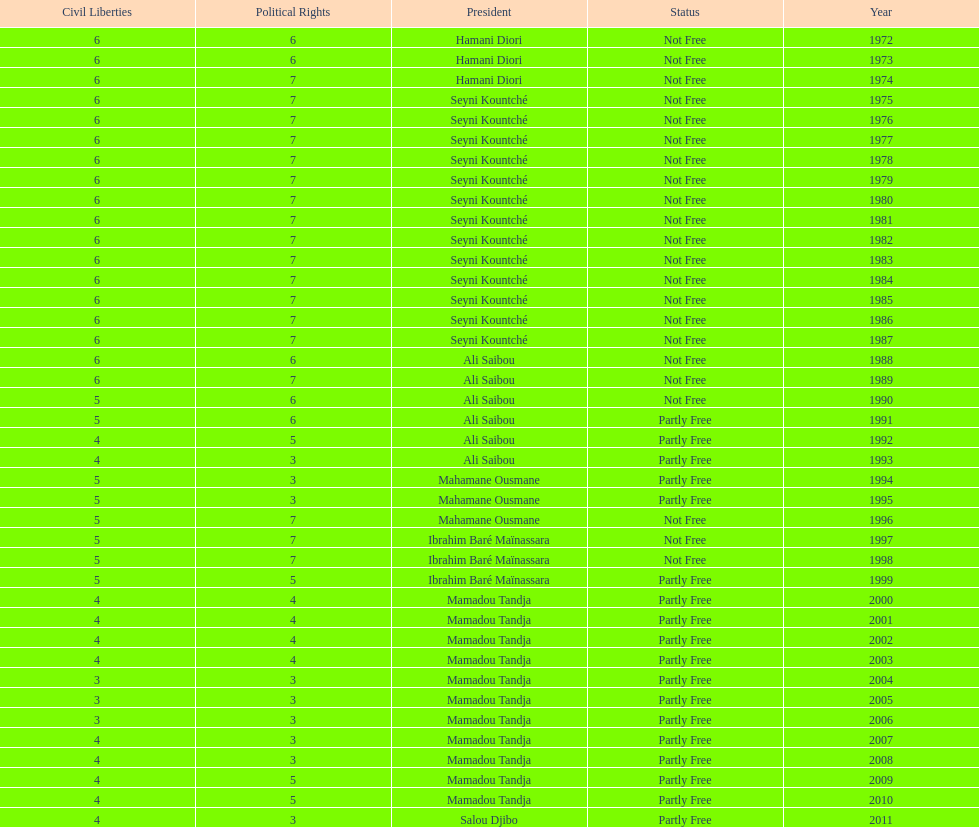Who was president before mamadou tandja? Ibrahim Baré Maïnassara. Could you parse the entire table? {'header': ['Civil Liberties', 'Political Rights', 'President', 'Status', 'Year'], 'rows': [['6', '6', 'Hamani Diori', 'Not Free', '1972'], ['6', '6', 'Hamani Diori', 'Not Free', '1973'], ['6', '7', 'Hamani Diori', 'Not Free', '1974'], ['6', '7', 'Seyni Kountché', 'Not Free', '1975'], ['6', '7', 'Seyni Kountché', 'Not Free', '1976'], ['6', '7', 'Seyni Kountché', 'Not Free', '1977'], ['6', '7', 'Seyni Kountché', 'Not Free', '1978'], ['6', '7', 'Seyni Kountché', 'Not Free', '1979'], ['6', '7', 'Seyni Kountché', 'Not Free', '1980'], ['6', '7', 'Seyni Kountché', 'Not Free', '1981'], ['6', '7', 'Seyni Kountché', 'Not Free', '1982'], ['6', '7', 'Seyni Kountché', 'Not Free', '1983'], ['6', '7', 'Seyni Kountché', 'Not Free', '1984'], ['6', '7', 'Seyni Kountché', 'Not Free', '1985'], ['6', '7', 'Seyni Kountché', 'Not Free', '1986'], ['6', '7', 'Seyni Kountché', 'Not Free', '1987'], ['6', '6', 'Ali Saibou', 'Not Free', '1988'], ['6', '7', 'Ali Saibou', 'Not Free', '1989'], ['5', '6', 'Ali Saibou', 'Not Free', '1990'], ['5', '6', 'Ali Saibou', 'Partly Free', '1991'], ['4', '5', 'Ali Saibou', 'Partly Free', '1992'], ['4', '3', 'Ali Saibou', 'Partly Free', '1993'], ['5', '3', 'Mahamane Ousmane', 'Partly Free', '1994'], ['5', '3', 'Mahamane Ousmane', 'Partly Free', '1995'], ['5', '7', 'Mahamane Ousmane', 'Not Free', '1996'], ['5', '7', 'Ibrahim Baré Maïnassara', 'Not Free', '1997'], ['5', '7', 'Ibrahim Baré Maïnassara', 'Not Free', '1998'], ['5', '5', 'Ibrahim Baré Maïnassara', 'Partly Free', '1999'], ['4', '4', 'Mamadou Tandja', 'Partly Free', '2000'], ['4', '4', 'Mamadou Tandja', 'Partly Free', '2001'], ['4', '4', 'Mamadou Tandja', 'Partly Free', '2002'], ['4', '4', 'Mamadou Tandja', 'Partly Free', '2003'], ['3', '3', 'Mamadou Tandja', 'Partly Free', '2004'], ['3', '3', 'Mamadou Tandja', 'Partly Free', '2005'], ['3', '3', 'Mamadou Tandja', 'Partly Free', '2006'], ['4', '3', 'Mamadou Tandja', 'Partly Free', '2007'], ['4', '3', 'Mamadou Tandja', 'Partly Free', '2008'], ['4', '5', 'Mamadou Tandja', 'Partly Free', '2009'], ['4', '5', 'Mamadou Tandja', 'Partly Free', '2010'], ['4', '3', 'Salou Djibo', 'Partly Free', '2011']]} 